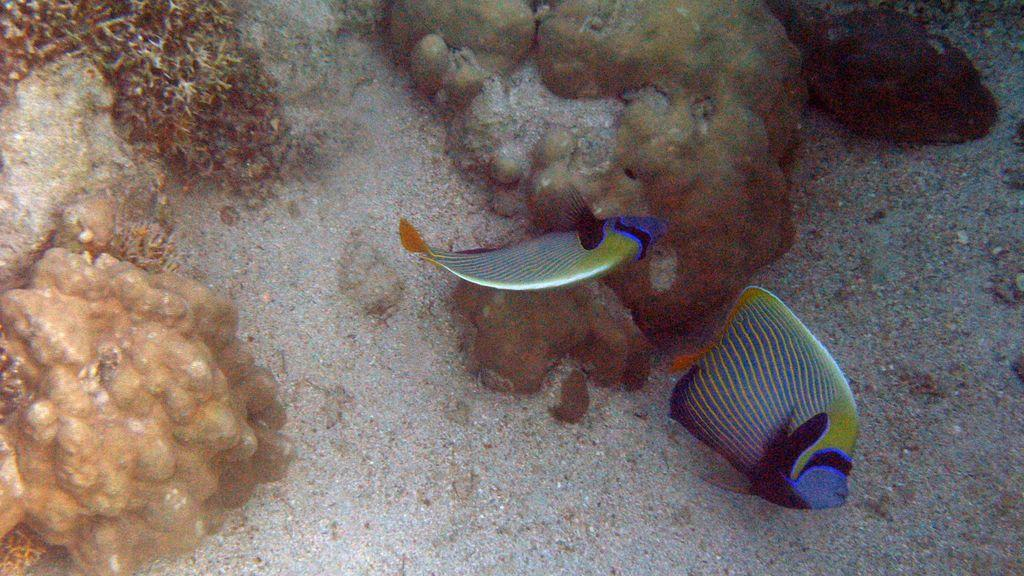Where was the image taken? The image is taken under the ocean. What can be seen in the center of the image? There are two fishes in the center of the image. How can the fishes be distinguished from each other? The fishes are in different colors. What is visible on the top of the image? There are stones and plants on the top of the image. What type of pipe can be seen in the image? There is no pipe present in the image; it is taken under the ocean and features two fishes, stones, and plants. What grade is the image taken in? The image is not taken in a school setting, so there is no grade associated with it. 